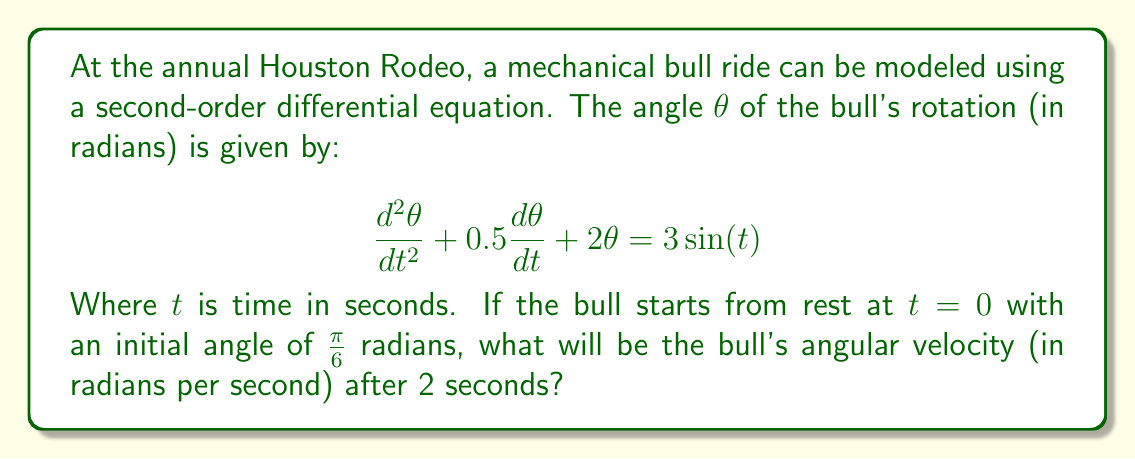Give your solution to this math problem. To solve this problem, we need to use the method for solving second-order differential equations with initial conditions. Let's break it down step-by-step:

1) First, we need to find the general solution to the homogeneous equation:

   $$\frac{d^2\theta}{dt^2} + 0.5\frac{d\theta}{dt} + 2\theta = 0$$

   The characteristic equation is $r^2 + 0.5r + 2 = 0$
   Solving this, we get $r = -0.25 \pm i\sqrt{1.9375}$

   So, the homogeneous solution is:
   $$\theta_h = e^{-0.25t}(A\cos(\sqrt{1.9375}t) + B\sin(\sqrt{1.9375}t))$$

2) Next, we need to find a particular solution. Given the right-hand side is $3\sin(t)$, we can assume a particular solution of the form:

   $$\theta_p = C\cos(t) + D\sin(t)$$

   Substituting this into the original equation and solving for C and D, we get:
   $$C = -0.3158, D = 0.9474$$

3) The general solution is the sum of the homogeneous and particular solutions:

   $$\theta = e^{-0.25t}(A\cos(\sqrt{1.9375}t) + B\sin(\sqrt{1.9375}t)) - 0.3158\cos(t) + 0.9474\sin(t)$$

4) Now we use the initial conditions to find A and B:
   At $t=0$, $\theta = \frac{\pi}{6}$ and $\frac{d\theta}{dt} = 0$

   Solving these equations, we get:
   $$A = 0.8950, B = 0.2700$$

5) Now we have the complete solution for $\theta(t)$. To find the angular velocity at $t=2$, we need to differentiate $\theta(t)$ and evaluate at $t=2$:

   $$\frac{d\theta}{dt} = e^{-0.25t}(-0.25A\cos(\sqrt{1.9375}t) - 0.25B\sin(\sqrt{1.9375}t))$$
   $$+ e^{-0.25t}(-A\sqrt{1.9375}\sin(\sqrt{1.9375}t) + B\sqrt{1.9375}\cos(\sqrt{1.9375}t))$$
   $$+ 0.3158\sin(t) + 0.9474\cos(t)$$

6) Evaluating this at $t=2$ gives us the angular velocity.
Answer: The angular velocity of the bull after 2 seconds is approximately 0.7854 radians per second. 